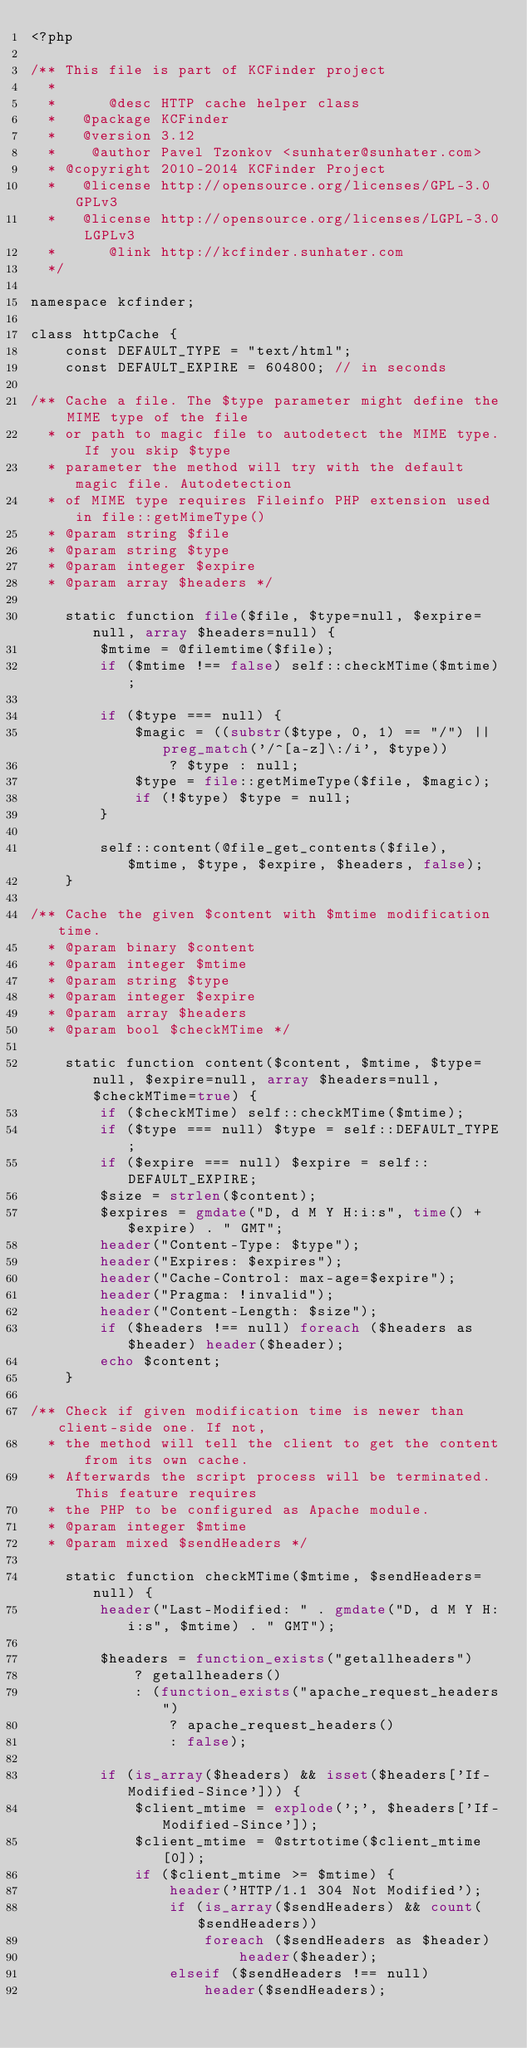<code> <loc_0><loc_0><loc_500><loc_500><_PHP_><?php

/** This file is part of KCFinder project
  *
  *      @desc HTTP cache helper class
  *   @package KCFinder
  *   @version 3.12
  *    @author Pavel Tzonkov <sunhater@sunhater.com>
  * @copyright 2010-2014 KCFinder Project
  *   @license http://opensource.org/licenses/GPL-3.0 GPLv3
  *   @license http://opensource.org/licenses/LGPL-3.0 LGPLv3
  *      @link http://kcfinder.sunhater.com
  */

namespace kcfinder;

class httpCache {
    const DEFAULT_TYPE = "text/html";
    const DEFAULT_EXPIRE = 604800; // in seconds

/** Cache a file. The $type parameter might define the MIME type of the file
  * or path to magic file to autodetect the MIME type. If you skip $type
  * parameter the method will try with the default magic file. Autodetection
  * of MIME type requires Fileinfo PHP extension used in file::getMimeType()
  * @param string $file
  * @param string $type
  * @param integer $expire
  * @param array $headers */

    static function file($file, $type=null, $expire=null, array $headers=null) {
        $mtime = @filemtime($file);
        if ($mtime !== false) self::checkMTime($mtime);

        if ($type === null) {
            $magic = ((substr($type, 0, 1) == "/") || preg_match('/^[a-z]\:/i', $type))
                ? $type : null;
            $type = file::getMimeType($file, $magic);
            if (!$type) $type = null;
        }

        self::content(@file_get_contents($file), $mtime, $type, $expire, $headers, false);
    }

/** Cache the given $content with $mtime modification time.
  * @param binary $content
  * @param integer $mtime
  * @param string $type
  * @param integer $expire
  * @param array $headers
  * @param bool $checkMTime */

    static function content($content, $mtime, $type=null, $expire=null, array $headers=null, $checkMTime=true) {
        if ($checkMTime) self::checkMTime($mtime);
        if ($type === null) $type = self::DEFAULT_TYPE;
        if ($expire === null) $expire = self::DEFAULT_EXPIRE;
        $size = strlen($content);
        $expires = gmdate("D, d M Y H:i:s", time() + $expire) . " GMT";
        header("Content-Type: $type");
        header("Expires: $expires");
        header("Cache-Control: max-age=$expire");
        header("Pragma: !invalid");
        header("Content-Length: $size");
        if ($headers !== null) foreach ($headers as $header) header($header);
        echo $content;
    }

/** Check if given modification time is newer than client-side one. If not,
  * the method will tell the client to get the content from its own cache.
  * Afterwards the script process will be terminated. This feature requires
  * the PHP to be configured as Apache module.
  * @param integer $mtime
  * @param mixed $sendHeaders */

    static function checkMTime($mtime, $sendHeaders=null) {
        header("Last-Modified: " . gmdate("D, d M Y H:i:s", $mtime) . " GMT");

        $headers = function_exists("getallheaders")
            ? getallheaders()
            : (function_exists("apache_request_headers")
                ? apache_request_headers()
                : false);

        if (is_array($headers) && isset($headers['If-Modified-Since'])) {
            $client_mtime = explode(';', $headers['If-Modified-Since']);
            $client_mtime = @strtotime($client_mtime[0]);
            if ($client_mtime >= $mtime) {
                header('HTTP/1.1 304 Not Modified');
                if (is_array($sendHeaders) && count($sendHeaders))
                    foreach ($sendHeaders as $header)
                        header($header);
                elseif ($sendHeaders !== null)
                    header($sendHeaders);</code> 